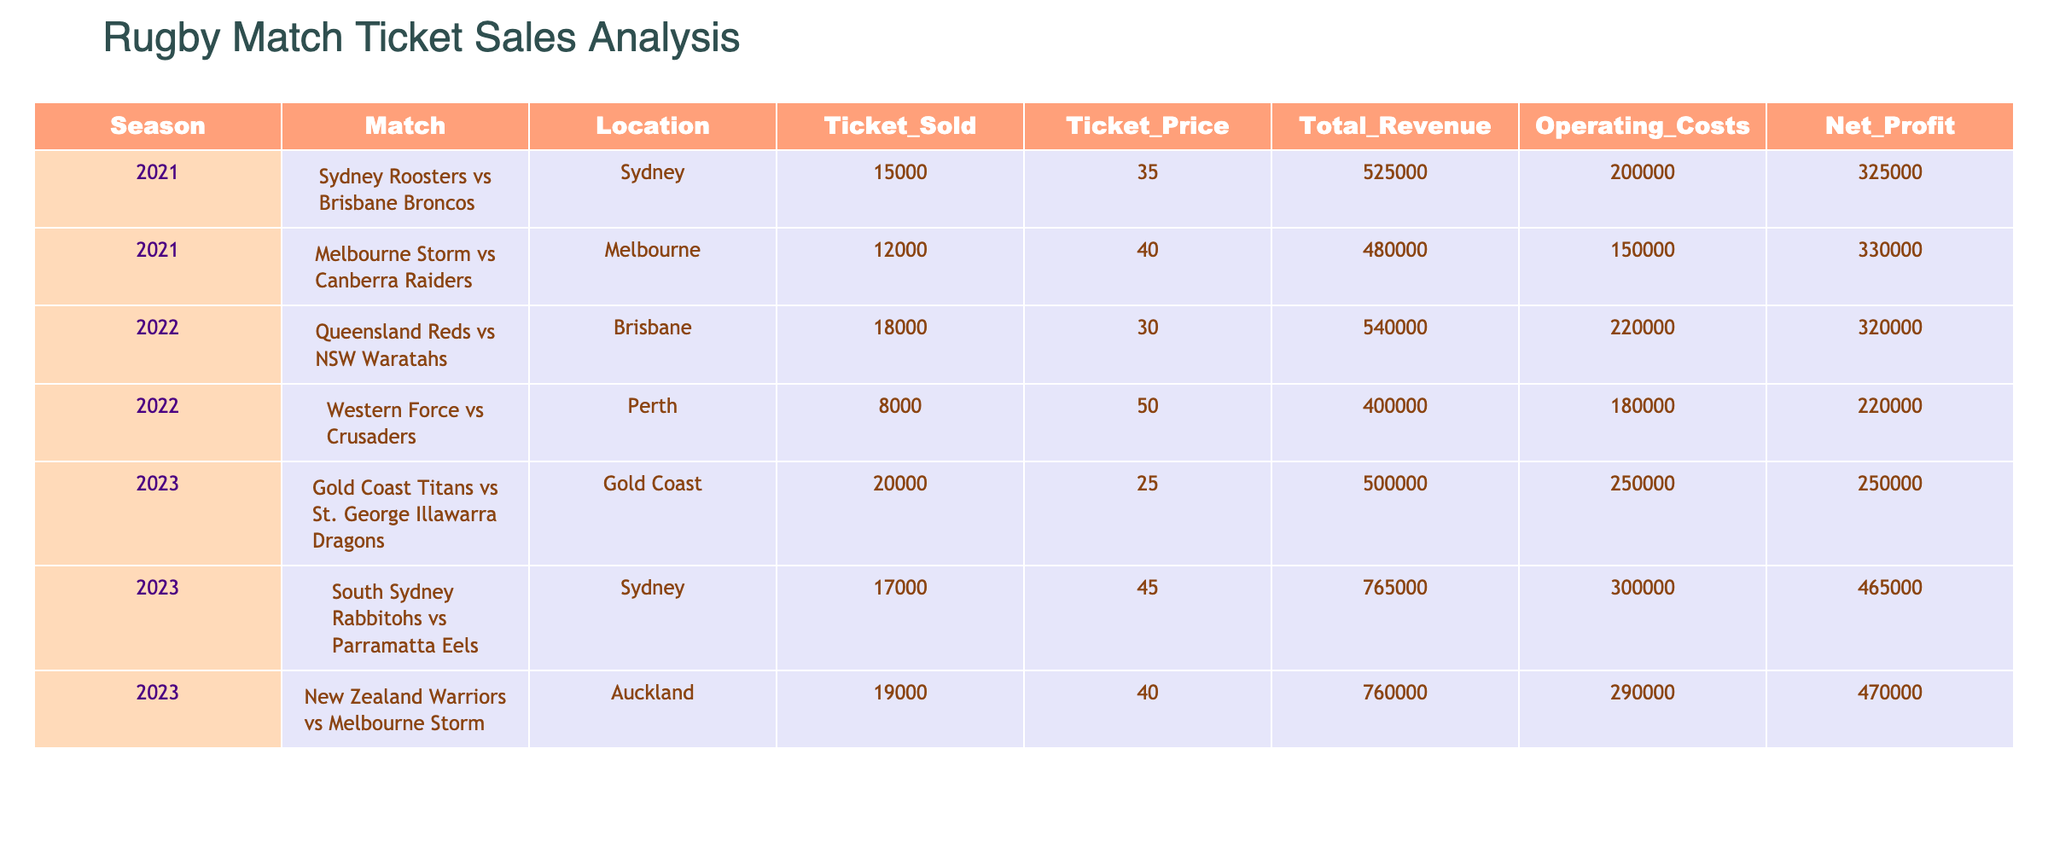What is the total revenue generated from the Sydney Roosters vs Brisbane Broncos match? From the table, the total revenue for the Sydney Roosters vs Brisbane Broncos match in 2021 is listed as 525000.
Answer: 525000 Which match had the highest net profit? By comparing the net profit values in the table, the match between South Sydney Rabbitohs vs Parramatta Eels in 2023 had the highest net profit of 465000.
Answer: 465000 What is the average ticket price across all matches? The ticket prices are 35, 40, 30, 50, 25, 45, and 40. Adding these gives 265, and dividing by 7 (the number of matches) gives an average of 37.5.
Answer: 37.5 Did any match have operating costs that exceeded total revenue? By examining the table, all matches show total revenue greater than their respective operating costs, confirming that none had operating costs that exceeded total revenue.
Answer: No What is the difference in net profit between the Queensland Reds vs NSW Waratahs match and the South Sydney Rabbitohs vs Parramatta Eels match? The net profit for the Queensland Reds vs NSW Waratahs match is 320000 and for the South Sydney Rabbitohs vs Parramatta Eels match it is 465000. The difference is 465000 - 320000 = 145000.
Answer: 145000 What percentage of ticket sales were achieved in the 2022 season compared to 2021 and 2023 combined? The total ticket sales for 2021 are 15000 + 12000 = 27000, for 2022 are 18000 + 8000 = 26000, and for 2023 are 20000 + 17000 + 19000 = 56000. The overall ticket sales are 27000 + 56000 = 83000. The percentage for 2022 is (26000 / 83000) * 100 = 31.33%.
Answer: 31.33% Which location had the most matches and how many? From examining the table, Sydney recorded matches for the Sydney Roosters vs Brisbane Broncos and South Sydney Rabbitohs vs Parramatta Eels, totaling 2 matches, which is the highest compared to other locations.
Answer: 2 Was the ticket price for the match between New Zealand Warriors and Melbourne Storm higher than the average ticket price? The ticket price for the match was 40, and the average ticket price calculated earlier is 37.5. Since 40 is greater than 37.5, the statement is true.
Answer: Yes What is the overall net profit for the 2023 season? By adding the net profits for all matches in 2023: 250000 + 465000 + 470000 gives a total of 1185000.
Answer: 1185000 